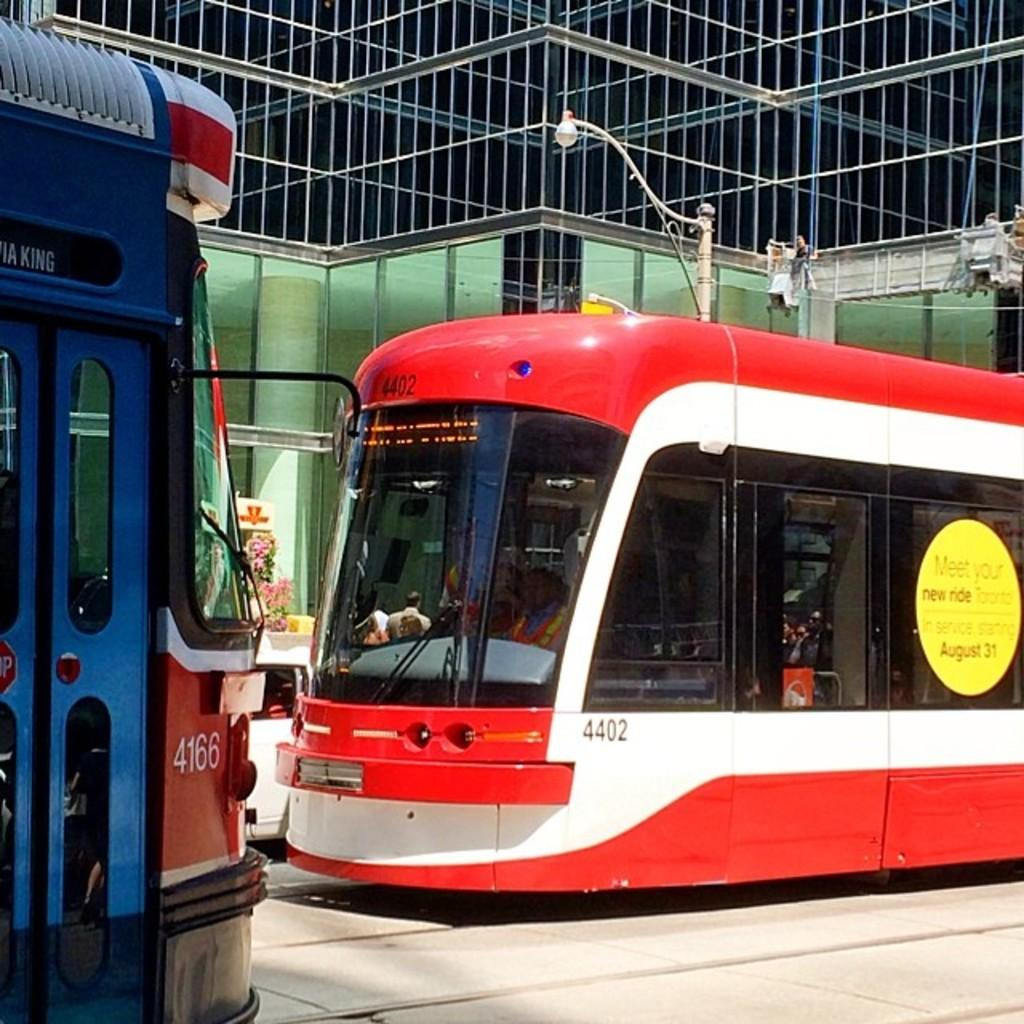What type of transportation can be seen in the image? There are two red color bullet trains in the image. Where are the bullet trains located? The bullet trains are parked at a station. Is there any additional structure visible in the image? Yes, there is a glass frame visible in the image. What type of plate is placed on the bed in the image? There is no plate or bed present in the image; it features two red color bullet trains parked at a station and a glass frame. 